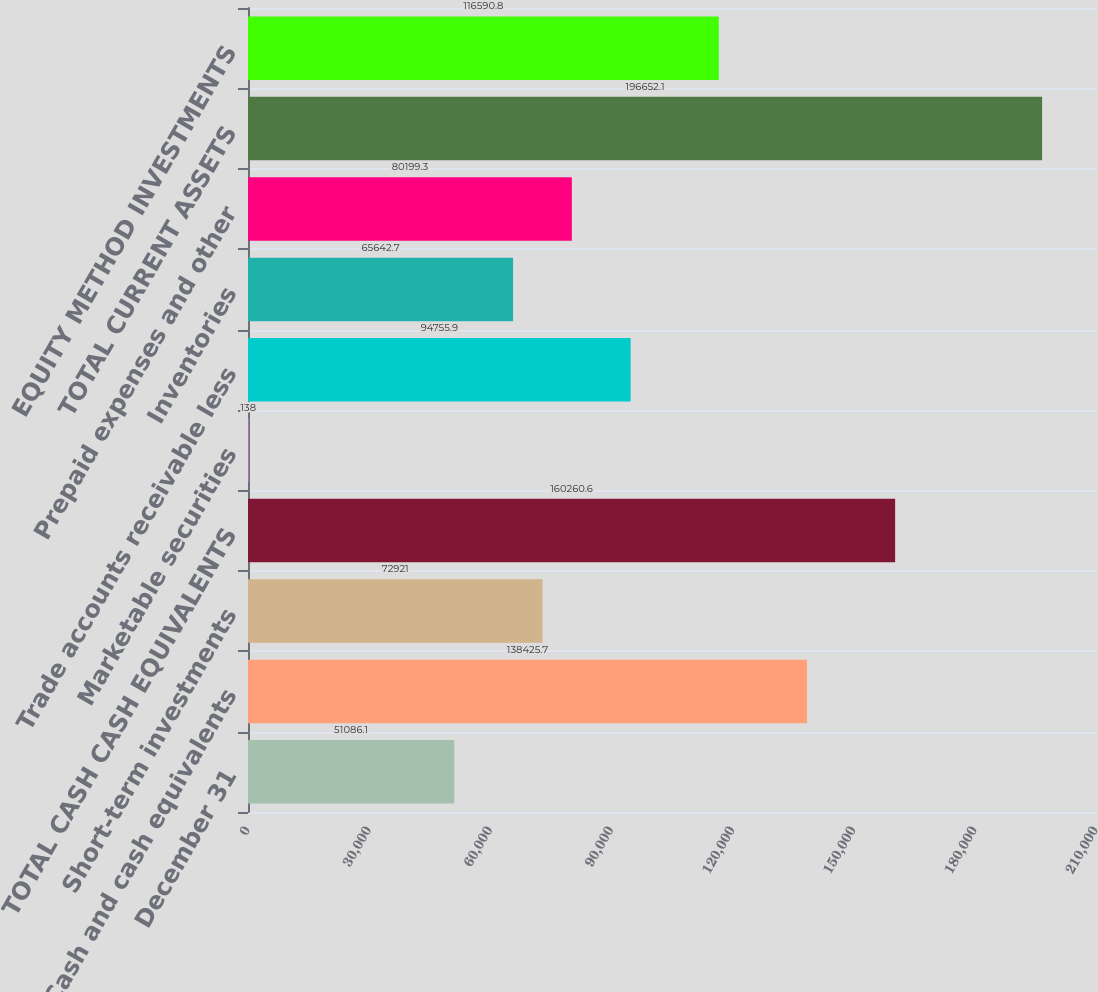Convert chart to OTSL. <chart><loc_0><loc_0><loc_500><loc_500><bar_chart><fcel>December 31<fcel>Cash and cash equivalents<fcel>Short-term investments<fcel>TOTAL CASH CASH EQUIVALENTS<fcel>Marketable securities<fcel>Trade accounts receivable less<fcel>Inventories<fcel>Prepaid expenses and other<fcel>TOTAL CURRENT ASSETS<fcel>EQUITY METHOD INVESTMENTS<nl><fcel>51086.1<fcel>138426<fcel>72921<fcel>160261<fcel>138<fcel>94755.9<fcel>65642.7<fcel>80199.3<fcel>196652<fcel>116591<nl></chart> 